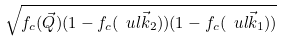<formula> <loc_0><loc_0><loc_500><loc_500>\sqrt { f _ { c } ( \vec { Q } ) ( 1 - f _ { c } ( \ u l { \vec { k } _ { 2 } } ) ) ( 1 - f _ { c } ( \ u l { \vec { k } _ { 1 } } ) ) }</formula> 